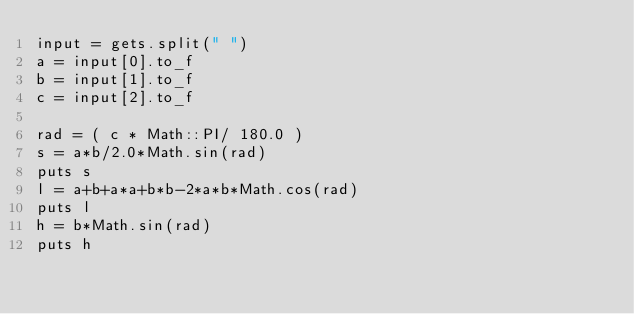Convert code to text. <code><loc_0><loc_0><loc_500><loc_500><_Ruby_>input = gets.split(" ")
a = input[0].to_f
b = input[1].to_f
c = input[2].to_f

rad = ( c * Math::PI/ 180.0 )
s = a*b/2.0*Math.sin(rad)
puts s
l = a+b+a*a+b*b-2*a*b*Math.cos(rad)
puts l
h = b*Math.sin(rad)
puts h</code> 